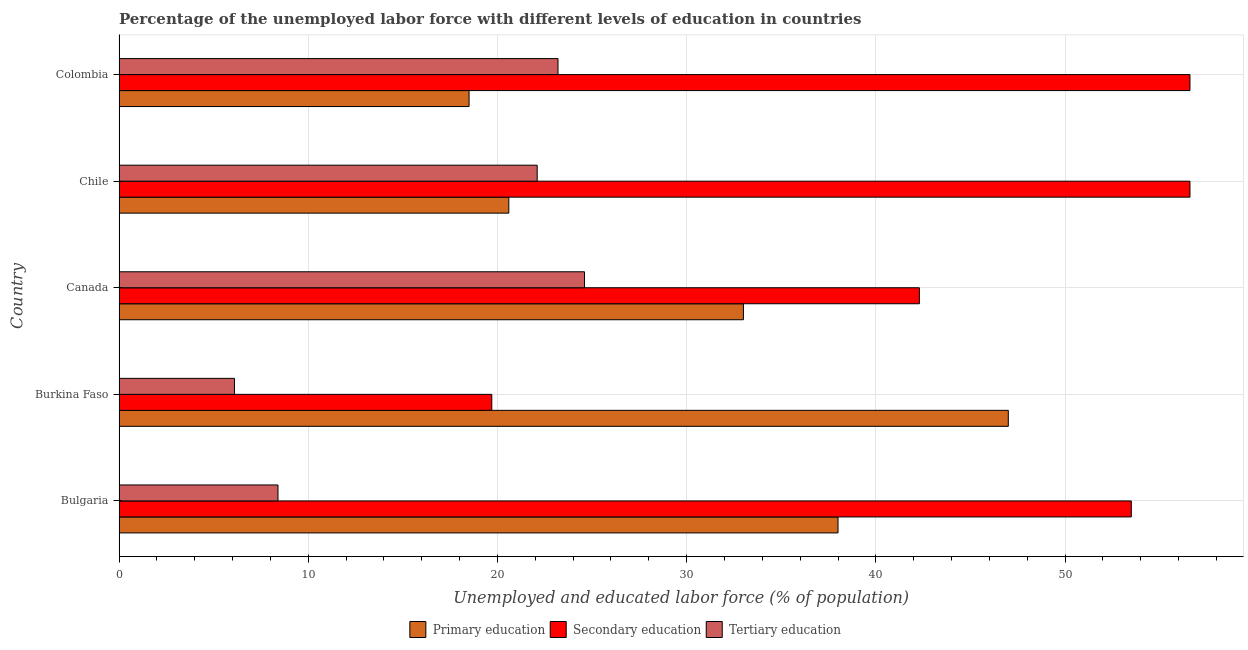How many different coloured bars are there?
Your response must be concise. 3. How many groups of bars are there?
Keep it short and to the point. 5. What is the percentage of labor force who received tertiary education in Bulgaria?
Offer a terse response. 8.4. Across all countries, what is the minimum percentage of labor force who received tertiary education?
Keep it short and to the point. 6.1. In which country was the percentage of labor force who received secondary education minimum?
Make the answer very short. Burkina Faso. What is the total percentage of labor force who received secondary education in the graph?
Make the answer very short. 228.7. What is the difference between the percentage of labor force who received tertiary education in Burkina Faso and that in Colombia?
Provide a short and direct response. -17.1. What is the difference between the percentage of labor force who received tertiary education in Canada and the percentage of labor force who received secondary education in Chile?
Your answer should be compact. -32. What is the average percentage of labor force who received tertiary education per country?
Your response must be concise. 16.88. What is the difference between the percentage of labor force who received tertiary education and percentage of labor force who received primary education in Canada?
Provide a succinct answer. -8.4. In how many countries, is the percentage of labor force who received primary education greater than 8 %?
Offer a very short reply. 5. What is the ratio of the percentage of labor force who received primary education in Burkina Faso to that in Chile?
Provide a short and direct response. 2.28. Is the percentage of labor force who received secondary education in Bulgaria less than that in Colombia?
Make the answer very short. Yes. What is the difference between the highest and the lowest percentage of labor force who received secondary education?
Your answer should be very brief. 36.9. What does the 1st bar from the top in Burkina Faso represents?
Provide a short and direct response. Tertiary education. What does the 2nd bar from the bottom in Colombia represents?
Give a very brief answer. Secondary education. How many bars are there?
Provide a succinct answer. 15. Are all the bars in the graph horizontal?
Your answer should be very brief. Yes. Does the graph contain grids?
Your answer should be compact. Yes. What is the title of the graph?
Offer a terse response. Percentage of the unemployed labor force with different levels of education in countries. Does "Coal sources" appear as one of the legend labels in the graph?
Make the answer very short. No. What is the label or title of the X-axis?
Offer a terse response. Unemployed and educated labor force (% of population). What is the label or title of the Y-axis?
Your response must be concise. Country. What is the Unemployed and educated labor force (% of population) in Primary education in Bulgaria?
Ensure brevity in your answer.  38. What is the Unemployed and educated labor force (% of population) of Secondary education in Bulgaria?
Make the answer very short. 53.5. What is the Unemployed and educated labor force (% of population) of Tertiary education in Bulgaria?
Provide a short and direct response. 8.4. What is the Unemployed and educated labor force (% of population) of Secondary education in Burkina Faso?
Make the answer very short. 19.7. What is the Unemployed and educated labor force (% of population) in Tertiary education in Burkina Faso?
Provide a succinct answer. 6.1. What is the Unemployed and educated labor force (% of population) in Primary education in Canada?
Give a very brief answer. 33. What is the Unemployed and educated labor force (% of population) in Secondary education in Canada?
Give a very brief answer. 42.3. What is the Unemployed and educated labor force (% of population) of Tertiary education in Canada?
Keep it short and to the point. 24.6. What is the Unemployed and educated labor force (% of population) of Primary education in Chile?
Provide a short and direct response. 20.6. What is the Unemployed and educated labor force (% of population) in Secondary education in Chile?
Your answer should be compact. 56.6. What is the Unemployed and educated labor force (% of population) of Tertiary education in Chile?
Your answer should be very brief. 22.1. What is the Unemployed and educated labor force (% of population) of Primary education in Colombia?
Your answer should be very brief. 18.5. What is the Unemployed and educated labor force (% of population) in Secondary education in Colombia?
Offer a terse response. 56.6. What is the Unemployed and educated labor force (% of population) in Tertiary education in Colombia?
Offer a very short reply. 23.2. Across all countries, what is the maximum Unemployed and educated labor force (% of population) of Secondary education?
Your answer should be very brief. 56.6. Across all countries, what is the maximum Unemployed and educated labor force (% of population) in Tertiary education?
Provide a succinct answer. 24.6. Across all countries, what is the minimum Unemployed and educated labor force (% of population) of Secondary education?
Your response must be concise. 19.7. Across all countries, what is the minimum Unemployed and educated labor force (% of population) of Tertiary education?
Keep it short and to the point. 6.1. What is the total Unemployed and educated labor force (% of population) in Primary education in the graph?
Provide a succinct answer. 157.1. What is the total Unemployed and educated labor force (% of population) of Secondary education in the graph?
Provide a succinct answer. 228.7. What is the total Unemployed and educated labor force (% of population) of Tertiary education in the graph?
Provide a short and direct response. 84.4. What is the difference between the Unemployed and educated labor force (% of population) of Secondary education in Bulgaria and that in Burkina Faso?
Provide a short and direct response. 33.8. What is the difference between the Unemployed and educated labor force (% of population) of Primary education in Bulgaria and that in Canada?
Your answer should be very brief. 5. What is the difference between the Unemployed and educated labor force (% of population) of Tertiary education in Bulgaria and that in Canada?
Make the answer very short. -16.2. What is the difference between the Unemployed and educated labor force (% of population) of Primary education in Bulgaria and that in Chile?
Your response must be concise. 17.4. What is the difference between the Unemployed and educated labor force (% of population) in Secondary education in Bulgaria and that in Chile?
Provide a succinct answer. -3.1. What is the difference between the Unemployed and educated labor force (% of population) of Tertiary education in Bulgaria and that in Chile?
Ensure brevity in your answer.  -13.7. What is the difference between the Unemployed and educated labor force (% of population) of Primary education in Bulgaria and that in Colombia?
Your answer should be compact. 19.5. What is the difference between the Unemployed and educated labor force (% of population) in Tertiary education in Bulgaria and that in Colombia?
Ensure brevity in your answer.  -14.8. What is the difference between the Unemployed and educated labor force (% of population) of Secondary education in Burkina Faso and that in Canada?
Keep it short and to the point. -22.6. What is the difference between the Unemployed and educated labor force (% of population) in Tertiary education in Burkina Faso and that in Canada?
Make the answer very short. -18.5. What is the difference between the Unemployed and educated labor force (% of population) of Primary education in Burkina Faso and that in Chile?
Make the answer very short. 26.4. What is the difference between the Unemployed and educated labor force (% of population) in Secondary education in Burkina Faso and that in Chile?
Your answer should be compact. -36.9. What is the difference between the Unemployed and educated labor force (% of population) of Secondary education in Burkina Faso and that in Colombia?
Make the answer very short. -36.9. What is the difference between the Unemployed and educated labor force (% of population) of Tertiary education in Burkina Faso and that in Colombia?
Offer a very short reply. -17.1. What is the difference between the Unemployed and educated labor force (% of population) in Primary education in Canada and that in Chile?
Offer a terse response. 12.4. What is the difference between the Unemployed and educated labor force (% of population) in Secondary education in Canada and that in Chile?
Make the answer very short. -14.3. What is the difference between the Unemployed and educated labor force (% of population) in Tertiary education in Canada and that in Chile?
Give a very brief answer. 2.5. What is the difference between the Unemployed and educated labor force (% of population) of Primary education in Canada and that in Colombia?
Your response must be concise. 14.5. What is the difference between the Unemployed and educated labor force (% of population) of Secondary education in Canada and that in Colombia?
Provide a short and direct response. -14.3. What is the difference between the Unemployed and educated labor force (% of population) in Tertiary education in Chile and that in Colombia?
Offer a very short reply. -1.1. What is the difference between the Unemployed and educated labor force (% of population) of Primary education in Bulgaria and the Unemployed and educated labor force (% of population) of Secondary education in Burkina Faso?
Keep it short and to the point. 18.3. What is the difference between the Unemployed and educated labor force (% of population) of Primary education in Bulgaria and the Unemployed and educated labor force (% of population) of Tertiary education in Burkina Faso?
Provide a short and direct response. 31.9. What is the difference between the Unemployed and educated labor force (% of population) in Secondary education in Bulgaria and the Unemployed and educated labor force (% of population) in Tertiary education in Burkina Faso?
Provide a succinct answer. 47.4. What is the difference between the Unemployed and educated labor force (% of population) of Secondary education in Bulgaria and the Unemployed and educated labor force (% of population) of Tertiary education in Canada?
Your answer should be compact. 28.9. What is the difference between the Unemployed and educated labor force (% of population) of Primary education in Bulgaria and the Unemployed and educated labor force (% of population) of Secondary education in Chile?
Your answer should be very brief. -18.6. What is the difference between the Unemployed and educated labor force (% of population) in Secondary education in Bulgaria and the Unemployed and educated labor force (% of population) in Tertiary education in Chile?
Your response must be concise. 31.4. What is the difference between the Unemployed and educated labor force (% of population) in Primary education in Bulgaria and the Unemployed and educated labor force (% of population) in Secondary education in Colombia?
Give a very brief answer. -18.6. What is the difference between the Unemployed and educated labor force (% of population) of Primary education in Bulgaria and the Unemployed and educated labor force (% of population) of Tertiary education in Colombia?
Provide a succinct answer. 14.8. What is the difference between the Unemployed and educated labor force (% of population) in Secondary education in Bulgaria and the Unemployed and educated labor force (% of population) in Tertiary education in Colombia?
Provide a short and direct response. 30.3. What is the difference between the Unemployed and educated labor force (% of population) in Primary education in Burkina Faso and the Unemployed and educated labor force (% of population) in Secondary education in Canada?
Provide a succinct answer. 4.7. What is the difference between the Unemployed and educated labor force (% of population) in Primary education in Burkina Faso and the Unemployed and educated labor force (% of population) in Tertiary education in Canada?
Give a very brief answer. 22.4. What is the difference between the Unemployed and educated labor force (% of population) in Primary education in Burkina Faso and the Unemployed and educated labor force (% of population) in Secondary education in Chile?
Make the answer very short. -9.6. What is the difference between the Unemployed and educated labor force (% of population) in Primary education in Burkina Faso and the Unemployed and educated labor force (% of population) in Tertiary education in Chile?
Your answer should be compact. 24.9. What is the difference between the Unemployed and educated labor force (% of population) of Primary education in Burkina Faso and the Unemployed and educated labor force (% of population) of Secondary education in Colombia?
Your response must be concise. -9.6. What is the difference between the Unemployed and educated labor force (% of population) of Primary education in Burkina Faso and the Unemployed and educated labor force (% of population) of Tertiary education in Colombia?
Give a very brief answer. 23.8. What is the difference between the Unemployed and educated labor force (% of population) of Primary education in Canada and the Unemployed and educated labor force (% of population) of Secondary education in Chile?
Your response must be concise. -23.6. What is the difference between the Unemployed and educated labor force (% of population) in Primary education in Canada and the Unemployed and educated labor force (% of population) in Tertiary education in Chile?
Offer a very short reply. 10.9. What is the difference between the Unemployed and educated labor force (% of population) in Secondary education in Canada and the Unemployed and educated labor force (% of population) in Tertiary education in Chile?
Provide a succinct answer. 20.2. What is the difference between the Unemployed and educated labor force (% of population) of Primary education in Canada and the Unemployed and educated labor force (% of population) of Secondary education in Colombia?
Provide a short and direct response. -23.6. What is the difference between the Unemployed and educated labor force (% of population) of Secondary education in Canada and the Unemployed and educated labor force (% of population) of Tertiary education in Colombia?
Your answer should be compact. 19.1. What is the difference between the Unemployed and educated labor force (% of population) in Primary education in Chile and the Unemployed and educated labor force (% of population) in Secondary education in Colombia?
Provide a short and direct response. -36. What is the difference between the Unemployed and educated labor force (% of population) of Primary education in Chile and the Unemployed and educated labor force (% of population) of Tertiary education in Colombia?
Provide a succinct answer. -2.6. What is the difference between the Unemployed and educated labor force (% of population) of Secondary education in Chile and the Unemployed and educated labor force (% of population) of Tertiary education in Colombia?
Provide a succinct answer. 33.4. What is the average Unemployed and educated labor force (% of population) of Primary education per country?
Your answer should be compact. 31.42. What is the average Unemployed and educated labor force (% of population) of Secondary education per country?
Your answer should be very brief. 45.74. What is the average Unemployed and educated labor force (% of population) in Tertiary education per country?
Keep it short and to the point. 16.88. What is the difference between the Unemployed and educated labor force (% of population) in Primary education and Unemployed and educated labor force (% of population) in Secondary education in Bulgaria?
Your answer should be compact. -15.5. What is the difference between the Unemployed and educated labor force (% of population) of Primary education and Unemployed and educated labor force (% of population) of Tertiary education in Bulgaria?
Provide a succinct answer. 29.6. What is the difference between the Unemployed and educated labor force (% of population) in Secondary education and Unemployed and educated labor force (% of population) in Tertiary education in Bulgaria?
Your response must be concise. 45.1. What is the difference between the Unemployed and educated labor force (% of population) of Primary education and Unemployed and educated labor force (% of population) of Secondary education in Burkina Faso?
Offer a terse response. 27.3. What is the difference between the Unemployed and educated labor force (% of population) in Primary education and Unemployed and educated labor force (% of population) in Tertiary education in Burkina Faso?
Provide a short and direct response. 40.9. What is the difference between the Unemployed and educated labor force (% of population) in Secondary education and Unemployed and educated labor force (% of population) in Tertiary education in Burkina Faso?
Keep it short and to the point. 13.6. What is the difference between the Unemployed and educated labor force (% of population) in Primary education and Unemployed and educated labor force (% of population) in Secondary education in Canada?
Your answer should be very brief. -9.3. What is the difference between the Unemployed and educated labor force (% of population) of Primary education and Unemployed and educated labor force (% of population) of Secondary education in Chile?
Keep it short and to the point. -36. What is the difference between the Unemployed and educated labor force (% of population) of Secondary education and Unemployed and educated labor force (% of population) of Tertiary education in Chile?
Provide a succinct answer. 34.5. What is the difference between the Unemployed and educated labor force (% of population) of Primary education and Unemployed and educated labor force (% of population) of Secondary education in Colombia?
Offer a terse response. -38.1. What is the difference between the Unemployed and educated labor force (% of population) of Primary education and Unemployed and educated labor force (% of population) of Tertiary education in Colombia?
Provide a short and direct response. -4.7. What is the difference between the Unemployed and educated labor force (% of population) of Secondary education and Unemployed and educated labor force (% of population) of Tertiary education in Colombia?
Ensure brevity in your answer.  33.4. What is the ratio of the Unemployed and educated labor force (% of population) of Primary education in Bulgaria to that in Burkina Faso?
Offer a terse response. 0.81. What is the ratio of the Unemployed and educated labor force (% of population) of Secondary education in Bulgaria to that in Burkina Faso?
Your answer should be very brief. 2.72. What is the ratio of the Unemployed and educated labor force (% of population) in Tertiary education in Bulgaria to that in Burkina Faso?
Make the answer very short. 1.38. What is the ratio of the Unemployed and educated labor force (% of population) of Primary education in Bulgaria to that in Canada?
Your response must be concise. 1.15. What is the ratio of the Unemployed and educated labor force (% of population) of Secondary education in Bulgaria to that in Canada?
Make the answer very short. 1.26. What is the ratio of the Unemployed and educated labor force (% of population) in Tertiary education in Bulgaria to that in Canada?
Offer a very short reply. 0.34. What is the ratio of the Unemployed and educated labor force (% of population) of Primary education in Bulgaria to that in Chile?
Offer a very short reply. 1.84. What is the ratio of the Unemployed and educated labor force (% of population) of Secondary education in Bulgaria to that in Chile?
Provide a short and direct response. 0.95. What is the ratio of the Unemployed and educated labor force (% of population) in Tertiary education in Bulgaria to that in Chile?
Keep it short and to the point. 0.38. What is the ratio of the Unemployed and educated labor force (% of population) of Primary education in Bulgaria to that in Colombia?
Your answer should be compact. 2.05. What is the ratio of the Unemployed and educated labor force (% of population) in Secondary education in Bulgaria to that in Colombia?
Your answer should be compact. 0.95. What is the ratio of the Unemployed and educated labor force (% of population) in Tertiary education in Bulgaria to that in Colombia?
Offer a terse response. 0.36. What is the ratio of the Unemployed and educated labor force (% of population) in Primary education in Burkina Faso to that in Canada?
Your response must be concise. 1.42. What is the ratio of the Unemployed and educated labor force (% of population) of Secondary education in Burkina Faso to that in Canada?
Your answer should be compact. 0.47. What is the ratio of the Unemployed and educated labor force (% of population) in Tertiary education in Burkina Faso to that in Canada?
Your response must be concise. 0.25. What is the ratio of the Unemployed and educated labor force (% of population) in Primary education in Burkina Faso to that in Chile?
Your response must be concise. 2.28. What is the ratio of the Unemployed and educated labor force (% of population) of Secondary education in Burkina Faso to that in Chile?
Your answer should be compact. 0.35. What is the ratio of the Unemployed and educated labor force (% of population) in Tertiary education in Burkina Faso to that in Chile?
Ensure brevity in your answer.  0.28. What is the ratio of the Unemployed and educated labor force (% of population) of Primary education in Burkina Faso to that in Colombia?
Your response must be concise. 2.54. What is the ratio of the Unemployed and educated labor force (% of population) of Secondary education in Burkina Faso to that in Colombia?
Ensure brevity in your answer.  0.35. What is the ratio of the Unemployed and educated labor force (% of population) of Tertiary education in Burkina Faso to that in Colombia?
Offer a terse response. 0.26. What is the ratio of the Unemployed and educated labor force (% of population) of Primary education in Canada to that in Chile?
Provide a short and direct response. 1.6. What is the ratio of the Unemployed and educated labor force (% of population) in Secondary education in Canada to that in Chile?
Give a very brief answer. 0.75. What is the ratio of the Unemployed and educated labor force (% of population) of Tertiary education in Canada to that in Chile?
Offer a very short reply. 1.11. What is the ratio of the Unemployed and educated labor force (% of population) of Primary education in Canada to that in Colombia?
Make the answer very short. 1.78. What is the ratio of the Unemployed and educated labor force (% of population) in Secondary education in Canada to that in Colombia?
Keep it short and to the point. 0.75. What is the ratio of the Unemployed and educated labor force (% of population) in Tertiary education in Canada to that in Colombia?
Your answer should be very brief. 1.06. What is the ratio of the Unemployed and educated labor force (% of population) in Primary education in Chile to that in Colombia?
Offer a very short reply. 1.11. What is the ratio of the Unemployed and educated labor force (% of population) in Tertiary education in Chile to that in Colombia?
Ensure brevity in your answer.  0.95. What is the difference between the highest and the lowest Unemployed and educated labor force (% of population) in Primary education?
Provide a succinct answer. 28.5. What is the difference between the highest and the lowest Unemployed and educated labor force (% of population) of Secondary education?
Make the answer very short. 36.9. 